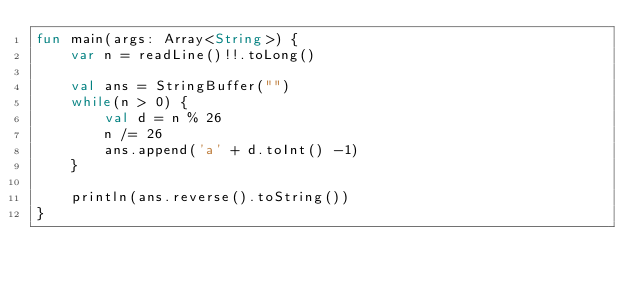<code> <loc_0><loc_0><loc_500><loc_500><_Kotlin_>fun main(args: Array<String>) {
    var n = readLine()!!.toLong()

    val ans = StringBuffer("")
    while(n > 0) {
        val d = n % 26
        n /= 26
        ans.append('a' + d.toInt() -1)
    }

    println(ans.reverse().toString())
}
</code> 